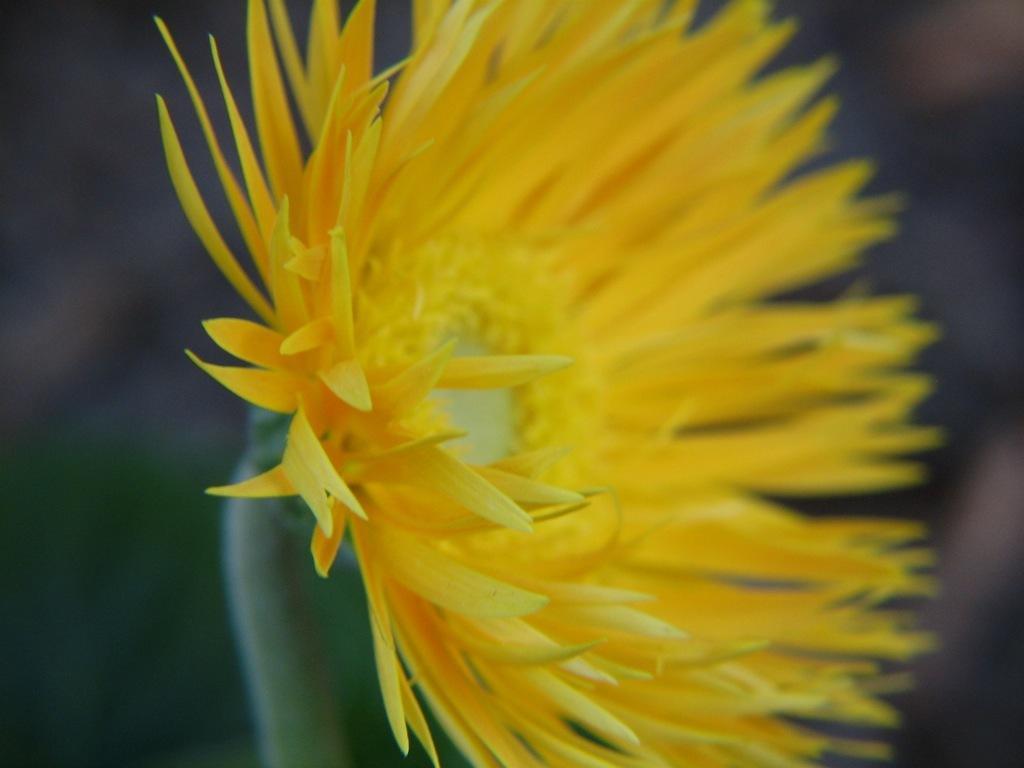In one or two sentences, can you explain what this image depicts? Here in this picture we can see a flower present over there. 